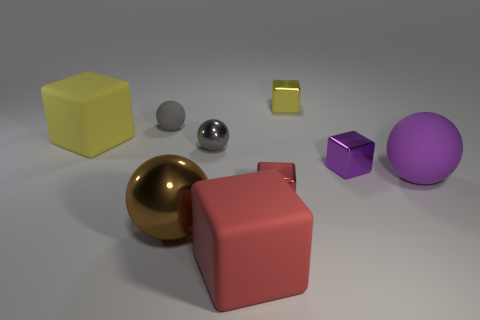Subtract 1 spheres. How many spheres are left? 3 Subtract all purple cubes. How many cubes are left? 4 Subtract all green spheres. Subtract all purple cubes. How many spheres are left? 4 Subtract all cubes. How many objects are left? 4 Add 1 tiny metal spheres. How many tiny metal spheres are left? 2 Add 8 blue rubber cubes. How many blue rubber cubes exist? 8 Subtract 2 red blocks. How many objects are left? 7 Subtract all small gray metallic spheres. Subtract all large rubber things. How many objects are left? 5 